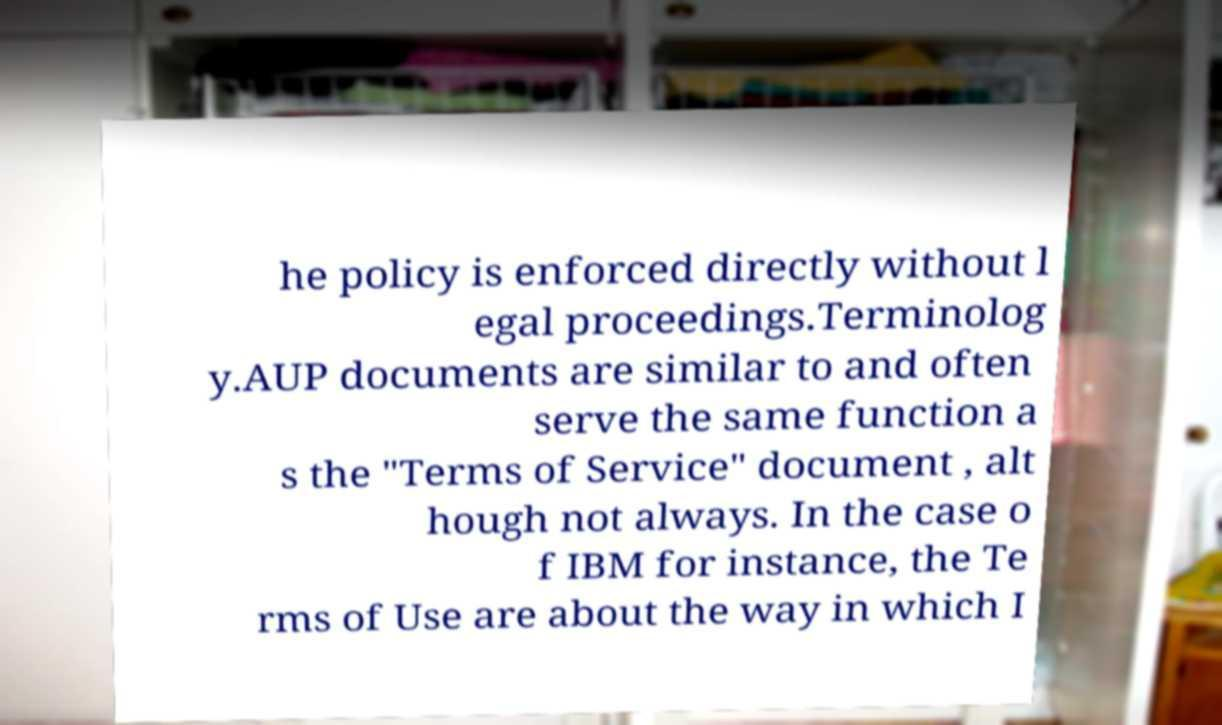Could you extract and type out the text from this image? he policy is enforced directly without l egal proceedings.Terminolog y.AUP documents are similar to and often serve the same function a s the "Terms of Service" document , alt hough not always. In the case o f IBM for instance, the Te rms of Use are about the way in which I 